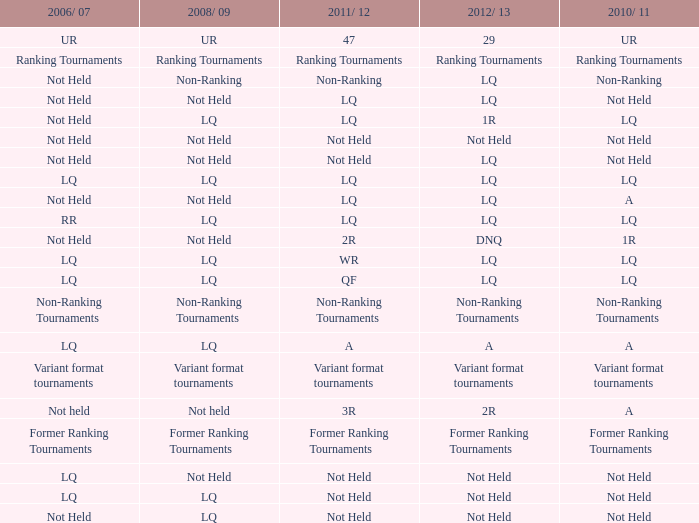What is 2006/07, when 2008/09 is LQ, and when 2010/11 is Not Held? LQ, Not Held. 